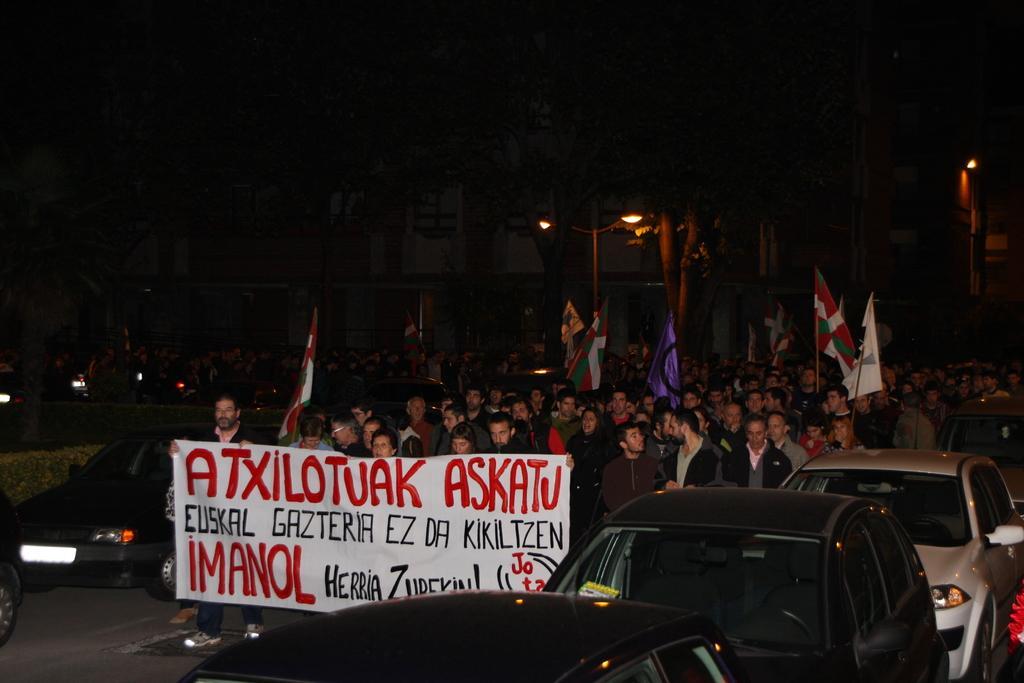How would you summarize this image in a sentence or two? In the center of the image there are people walking holding flags and banner. There are cars. There is a street light. 